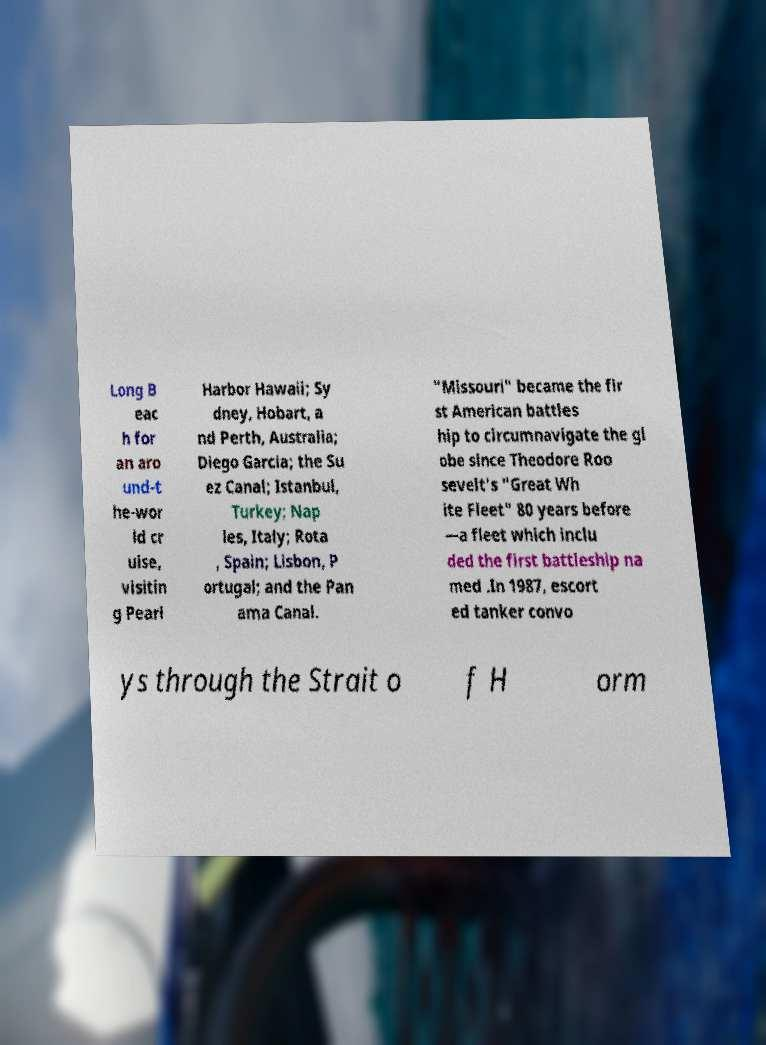Could you assist in decoding the text presented in this image and type it out clearly? Long B eac h for an aro und-t he-wor ld cr uise, visitin g Pearl Harbor Hawaii; Sy dney, Hobart, a nd Perth, Australia; Diego Garcia; the Su ez Canal; Istanbul, Turkey; Nap les, Italy; Rota , Spain; Lisbon, P ortugal; and the Pan ama Canal. "Missouri" became the fir st American battles hip to circumnavigate the gl obe since Theodore Roo sevelt's "Great Wh ite Fleet" 80 years before —a fleet which inclu ded the first battleship na med .In 1987, escort ed tanker convo ys through the Strait o f H orm 